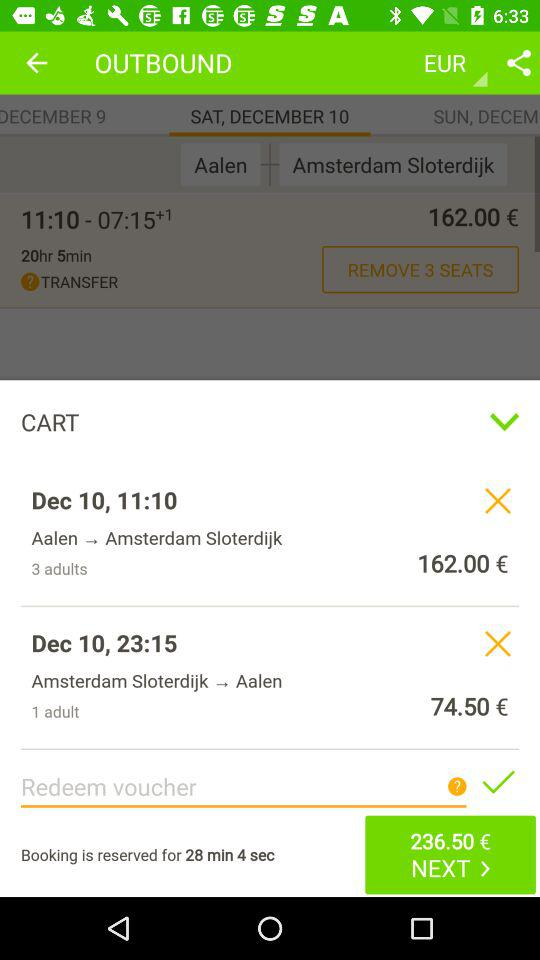What is the count of passengers travelling to Amsterdam Sloterdijk? The count of passengers is 3 adults. 